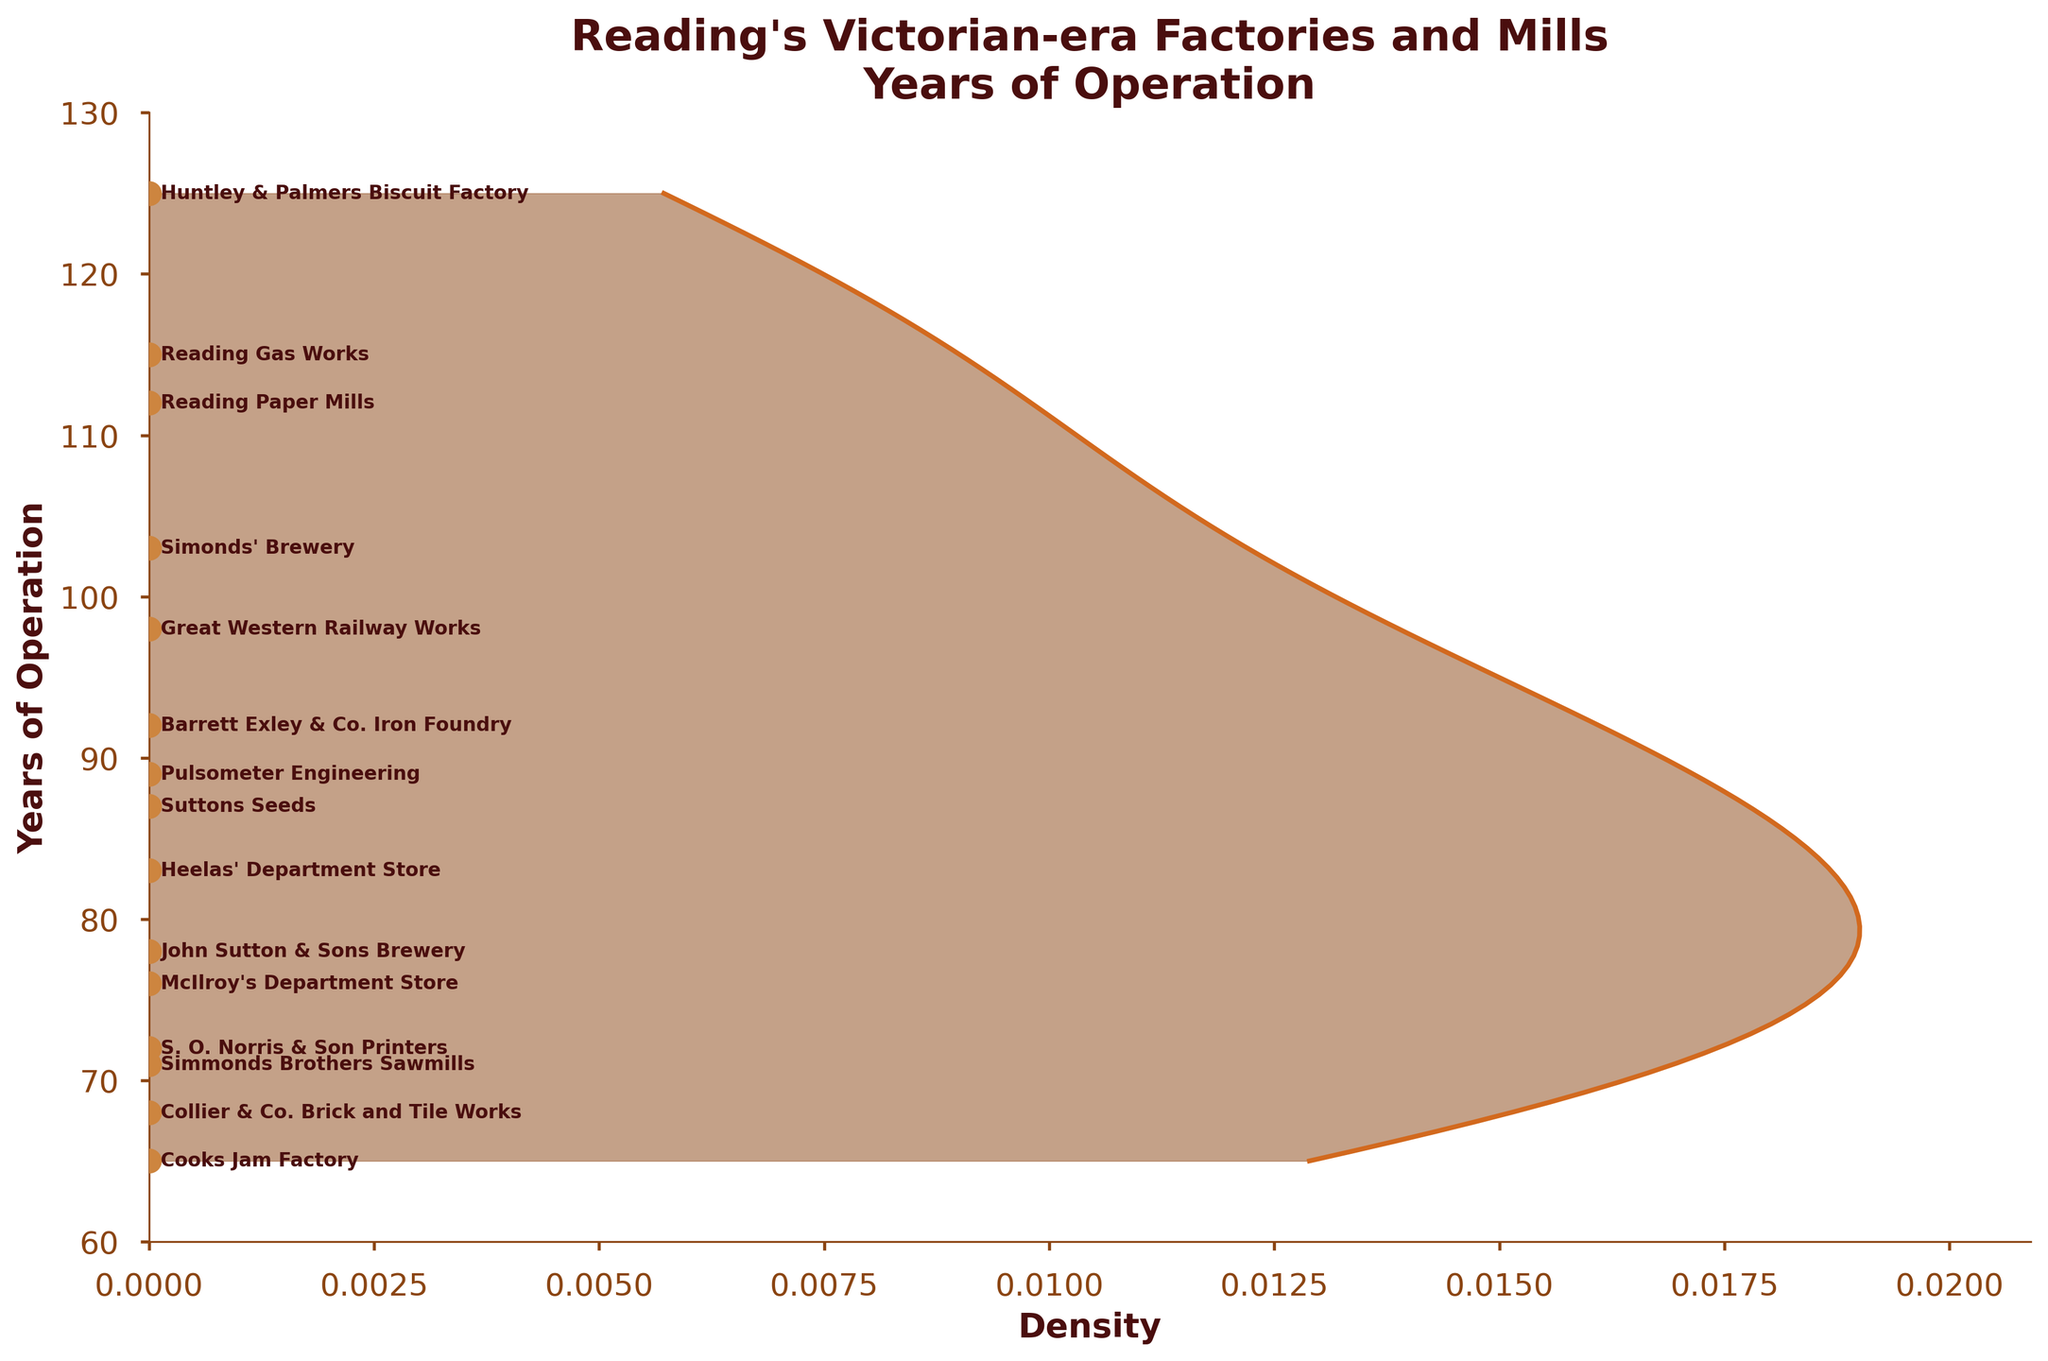How many data points are shown in the figure? The figure shows the length of operation for multiple factories and mills. Each data point corresponds to a factory or mill. We can count the number of points shown in the scatter plot to find the number of data points.
Answer: 15 What is the longest duration of operation for the factories and mills? We can look at the plotted points and read the label with the maximum value on the y-axis. The longest duration is labeled next to the corresponding point.
Answer: 125 years Which factory or mill had the shortest duration of operation? We can identify the point closest to the minimum value on the y-axis and read the label next to it. The name of the factory or mill with the shortest duration is written there.
Answer: Cooks Jam Factory What is the median length of operation for the factories and mills? To find the median, we need to list the durations in ascending order and locate the middle value. When listed, the durations are: 65, 68, 71, 72, 76, 78, 83, 87, 89, 92, 98, 103, 112, 115, 125. The middle (8th) value is the median.
Answer: 87 years Which factories or mills operated for more than 100 years? We need to identify the points on the scatter plot where the y-axis value is greater than 100 and read the labels next to them.
Answer: Huntley & Palmers Biscuit Factory, Simonds' Brewery, Reading Gas Works, Reading Paper Mills How does the density of operations change with duration? Observing the density plot, we look for areas where the curve is higher, indicating higher density, and where it is lower, indicating lower density. We can describe the general trend accordingly.
Answer: High density around 70-90 years, lower density at extremes What is the average length of operation for the factories and mills? To find the average, sum all the operations' years and divide by the number of data points. (125+78+92+103+87+68+112+71+83+76+65+89+72+115+98) / 15 = 1265 / 15
Answer: 84.3 years Which point represents the Heelas' Department Store? Identify the label "Heelas' Department Store" on the plot and check its position on the y-axis to find the corresponding duration.
Answer: 83 years How many factories and mills operated between 70 and 90 years? Look at the labels and count the points on the scatter plot that lie within the y-axis range of 70 to 90 years.
Answer: 5 factories and mills What is the mode of the lengths of operation, if any? The mode is the value that appears most frequently. Check the plotted data points to see if any duration is repeated.
Answer: No mode (all values are unique) 